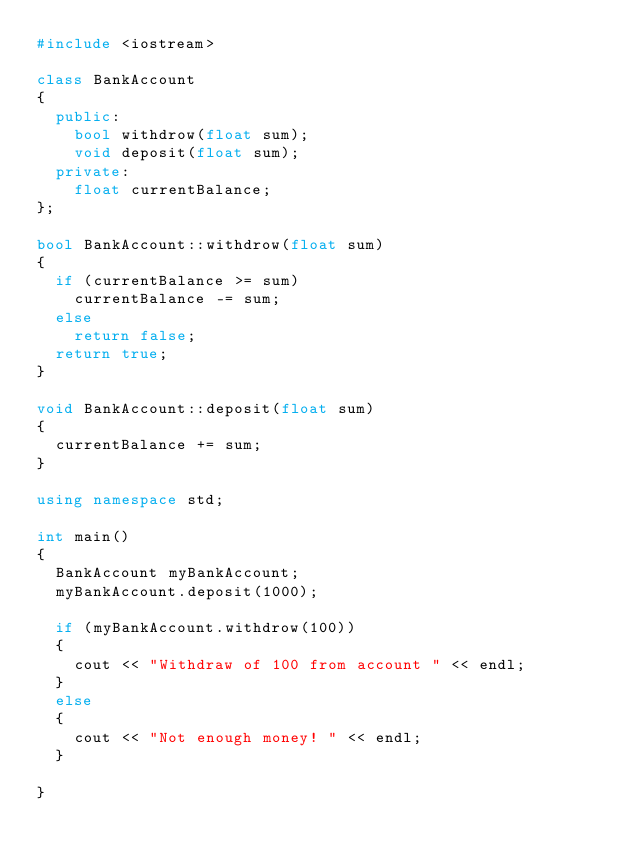Convert code to text. <code><loc_0><loc_0><loc_500><loc_500><_C++_>#include <iostream>

class BankAccount
{
  public:
    bool withdrow(float sum);
    void deposit(float sum);
  private:
    float currentBalance;
};

bool BankAccount::withdrow(float sum)
{
  if (currentBalance >= sum)
    currentBalance -= sum;
  else
    return false;
  return true;
}

void BankAccount::deposit(float sum)
{
  currentBalance += sum;
}

using namespace std;

int main()
{
  BankAccount myBankAccount;
  myBankAccount.deposit(1000);

  if (myBankAccount.withdrow(100))
  {
    cout << "Withdraw of 100 from account " << endl;
  }
  else
  {
    cout << "Not enough money! " << endl;
  }

}
</code> 